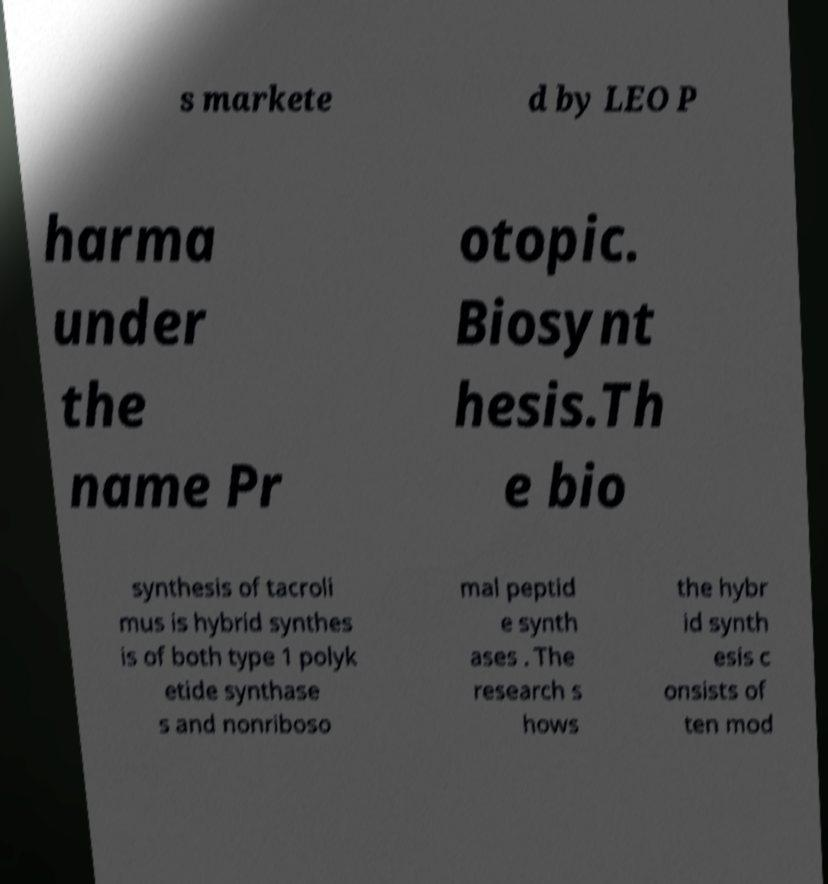What messages or text are displayed in this image? I need them in a readable, typed format. s markete d by LEO P harma under the name Pr otopic. Biosynt hesis.Th e bio synthesis of tacroli mus is hybrid synthes is of both type 1 polyk etide synthase s and nonriboso mal peptid e synth ases . The research s hows the hybr id synth esis c onsists of ten mod 